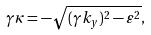Convert formula to latex. <formula><loc_0><loc_0><loc_500><loc_500>\gamma \kappa = - \sqrt { ( \gamma k _ { y } ) ^ { 2 } - \varepsilon ^ { 2 } } ,</formula> 